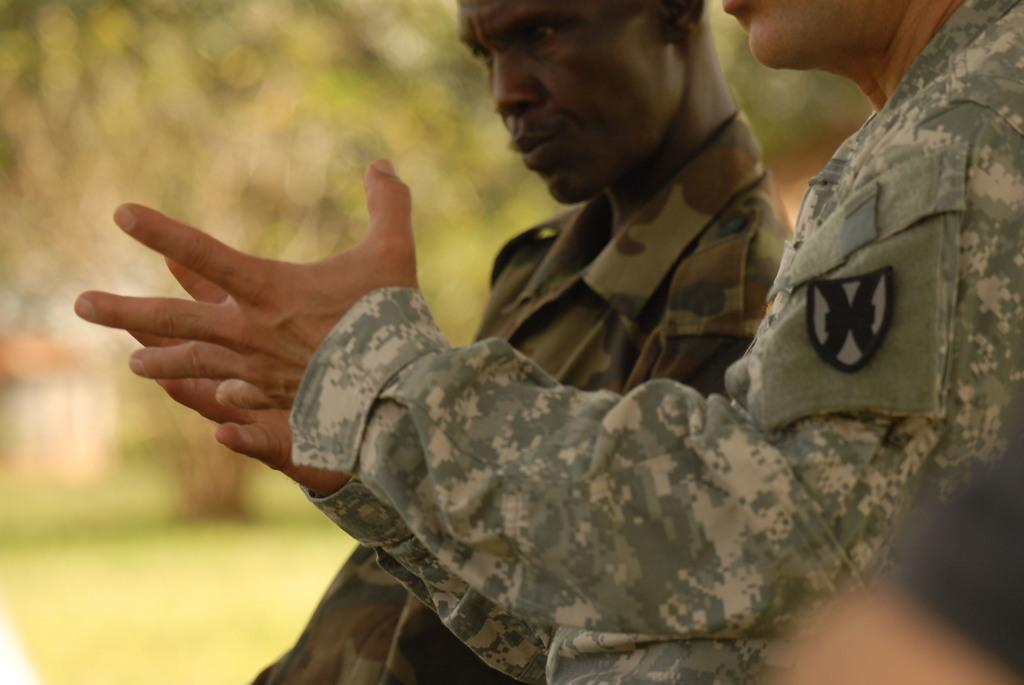How many army persons are in the image? There are two army persons in the image. What are the army persons wearing? The army persons are wearing uniforms. What can be seen in the background of the image? There might be trees and buildings in the background of the image. How would you describe the quality of the background image? The background image appears blurry. What type of crow can be seen flying over the army persons in the image? There is no crow present in the image. How does the hot weather affect the army persons in the image? The image does not provide any information about the weather, so it cannot be determined if it is hot or not. 